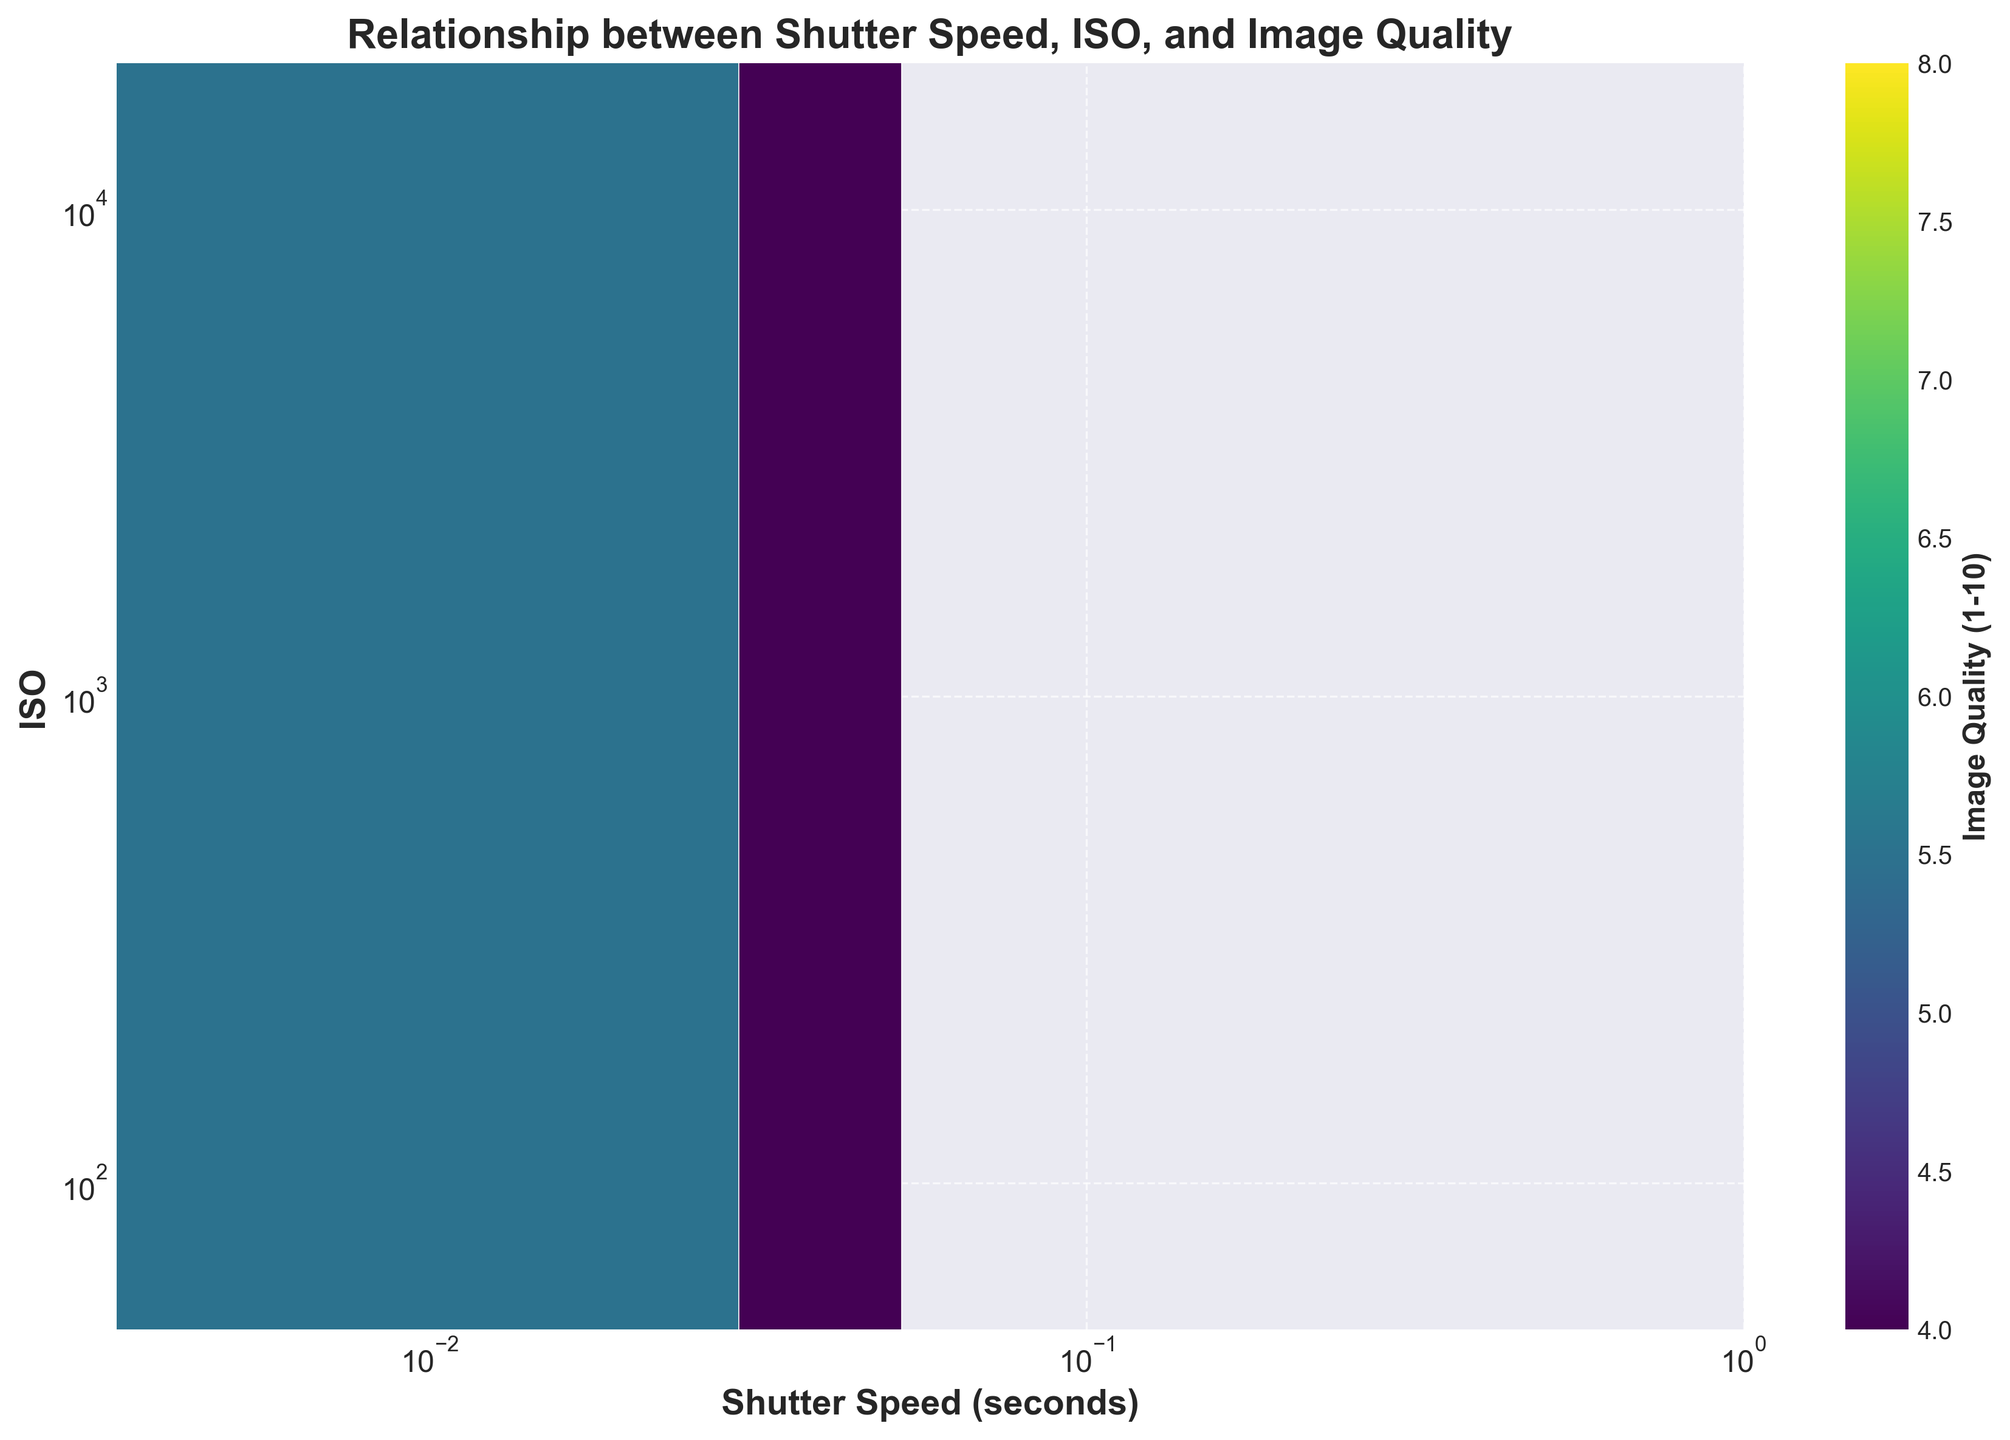What is the title of the plot? The title of the figure is written at the top of the plot. By observing the top area, you will see the heading.
Answer: Relationship between Shutter Speed, ISO, and Image Quality What are the x-axis and y-axis labels? The x-axis and y-axis labels are found along the respective axes. The x-axis is labeled at the bottom, and the y-axis label is on the left side.
Answer: Shutter Speed (seconds) and ISO What color represents the highest image quality on the plot? The color representing the highest image quality can be identified from the color bar. By finding the color that corresponds to the highest value on the image quality scale in the color bar, you get the answer.
Answer: Bright yellow In which range of ISO settings do we see the highest image quality for a shutter speed of around 1/125 seconds? To find this, locate the vertical line for 1/125 seconds on the x-axis, and observe the ISO range that contains the brightest yellow hexes.
Answer: Around 6400 Which area on the plot has the highest data density, indicated by the most compact hexagons? The highest data density area is where the hexagons are the most clustered together. Look for the area with tightly packed hexagons.
Answer: 1/15 to 1/60 seconds and 800 to 6400 ISO What is the general trend between ISO and shutter speed as indicated by the hexbin plot? The general trend can be observed by looking at the pattern of the hexagons' position and color intensity across the plot. Observe the relationship as either increasing, decreasing, or neutral.
Answer: Higher ISO settings are generally coupled with faster shutter speeds in this dataset How does image quality change with increasing shutter speed at a constant ISO of 3200? To answer this, focus on the hexagons along the ISO=3200 line and observe the change in color as you move across different shutter speed values.
Answer: The image quality slightly increases with faster shutter speeds For shutter speeds slower than 1/15 seconds, at what ISO range does image quality generally start to decrease? Investigate the x-axis for values slower than 1/15 seconds, then look at the color trends along the corresponding ISO values as the hexagons change color.
Answer: Less than 1600 ISO Is there any noticeable clustering of data points around certain ISO-shutter speed combinations? If yes, where? Look for clusters where many hexagons are densely packed and observe their locations within the grid.
Answer: Yes, around 1/15 seconds and ISO ranges of 1600 to 3200 How does image quality correlate with low ISO settings? Examine the hexbin plot hexagons located on the lower end of the ISO scale and observe the corresponding colors that represent image quality.
Answer: Lower ISO settings generally correspond to lower image quality 